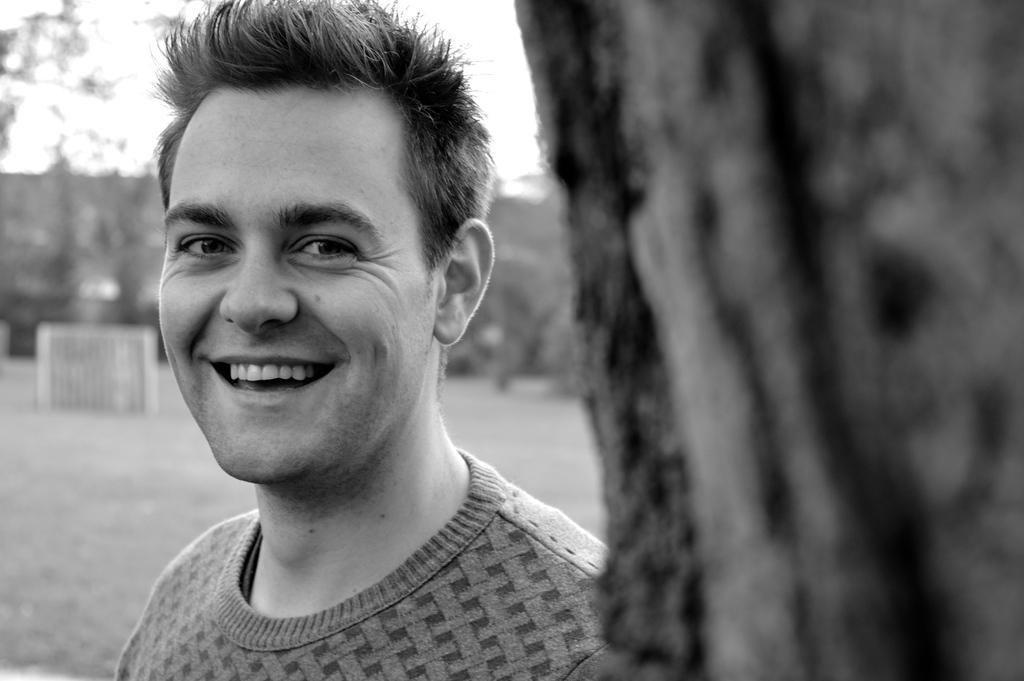What is the color scheme of the image? The image is black and white. What can be seen in the foreground on the right side? There is a tree trunk in the foreground on the right side. What is the man behind the tree trunk doing? The man is smiling. How would you describe the background of the image? The background of the image is blurred. What type of milk is the man holding in the image? There is no milk present in the image; the man is not holding anything. 